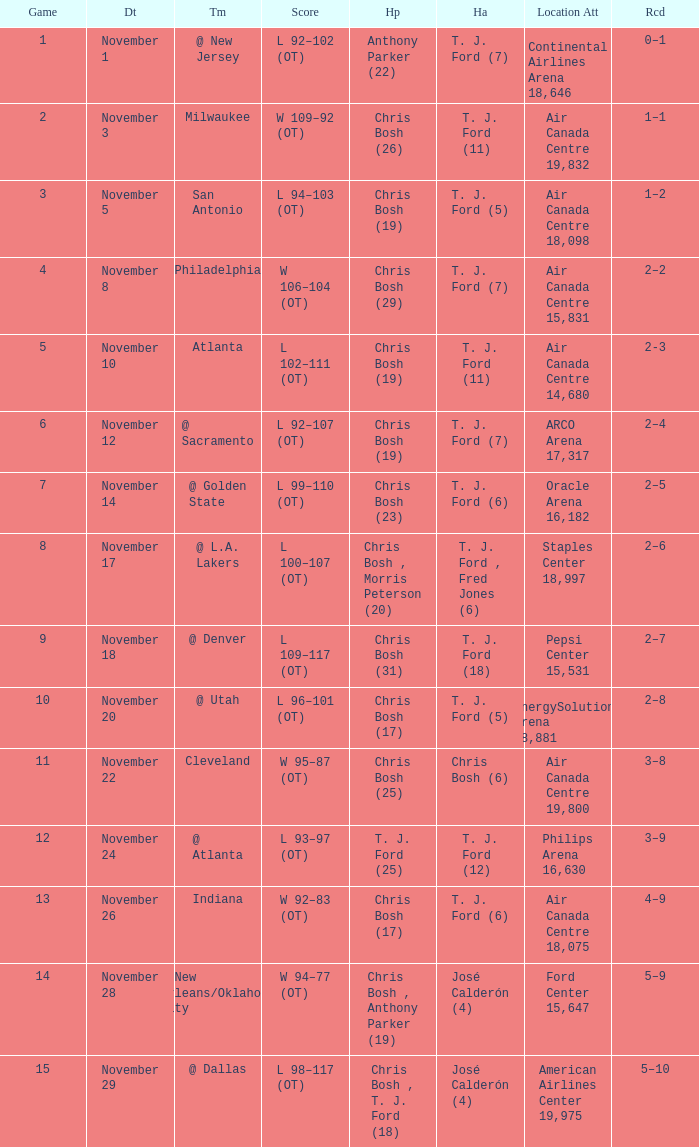What team played on November 28? @ New Orleans/Oklahoma City. 